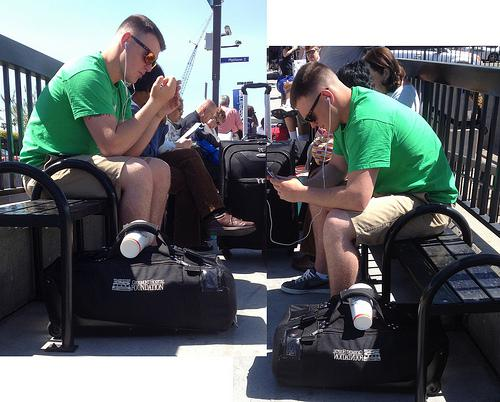Question: what type of scene is it?
Choices:
A. Outdoor.
B. Indoor.
C. Fall.
D. Winter.
Answer with the letter. Answer: A Question: what is cast?
Choices:
A. Sunlight.
B. Shade.
C. Reflection.
D. Shadow.
Answer with the letter. Answer: D Question: who are in the photo?
Choices:
A. Only women.
B. People.
C. Only men.
D. Cats.
Answer with the letter. Answer: B Question: what is the bench made of?
Choices:
A. Wood.
B. Stone.
C. Concrete.
D. Plastic.
Answer with the letter. Answer: A 